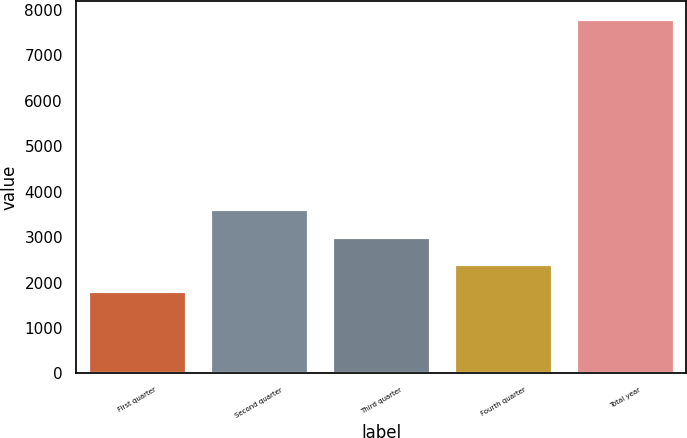Convert chart to OTSL. <chart><loc_0><loc_0><loc_500><loc_500><bar_chart><fcel>First quarter<fcel>Second quarter<fcel>Third quarter<fcel>Fourth quarter<fcel>Total year<nl><fcel>1813.1<fcel>3610.19<fcel>3011.16<fcel>2412.13<fcel>7803.4<nl></chart> 